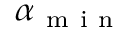<formula> <loc_0><loc_0><loc_500><loc_500>\alpha _ { m i n }</formula> 